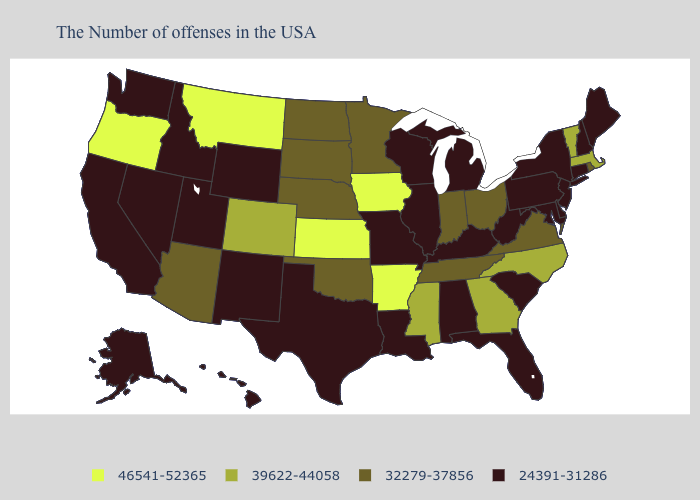Name the states that have a value in the range 39622-44058?
Give a very brief answer. Massachusetts, Vermont, North Carolina, Georgia, Mississippi, Colorado. What is the value of North Dakota?
Short answer required. 32279-37856. Does New Jersey have a lower value than Michigan?
Be succinct. No. What is the value of Missouri?
Keep it brief. 24391-31286. Among the states that border North Carolina , which have the highest value?
Give a very brief answer. Georgia. Name the states that have a value in the range 46541-52365?
Keep it brief. Arkansas, Iowa, Kansas, Montana, Oregon. Does Connecticut have a higher value than Washington?
Answer briefly. No. Which states have the lowest value in the MidWest?
Write a very short answer. Michigan, Wisconsin, Illinois, Missouri. What is the value of Oklahoma?
Keep it brief. 32279-37856. What is the lowest value in states that border Nevada?
Give a very brief answer. 24391-31286. Does New Hampshire have the same value as Arkansas?
Concise answer only. No. Name the states that have a value in the range 46541-52365?
Short answer required. Arkansas, Iowa, Kansas, Montana, Oregon. Among the states that border Wyoming , does Montana have the lowest value?
Quick response, please. No. What is the value of Mississippi?
Short answer required. 39622-44058. Which states have the highest value in the USA?
Short answer required. Arkansas, Iowa, Kansas, Montana, Oregon. 